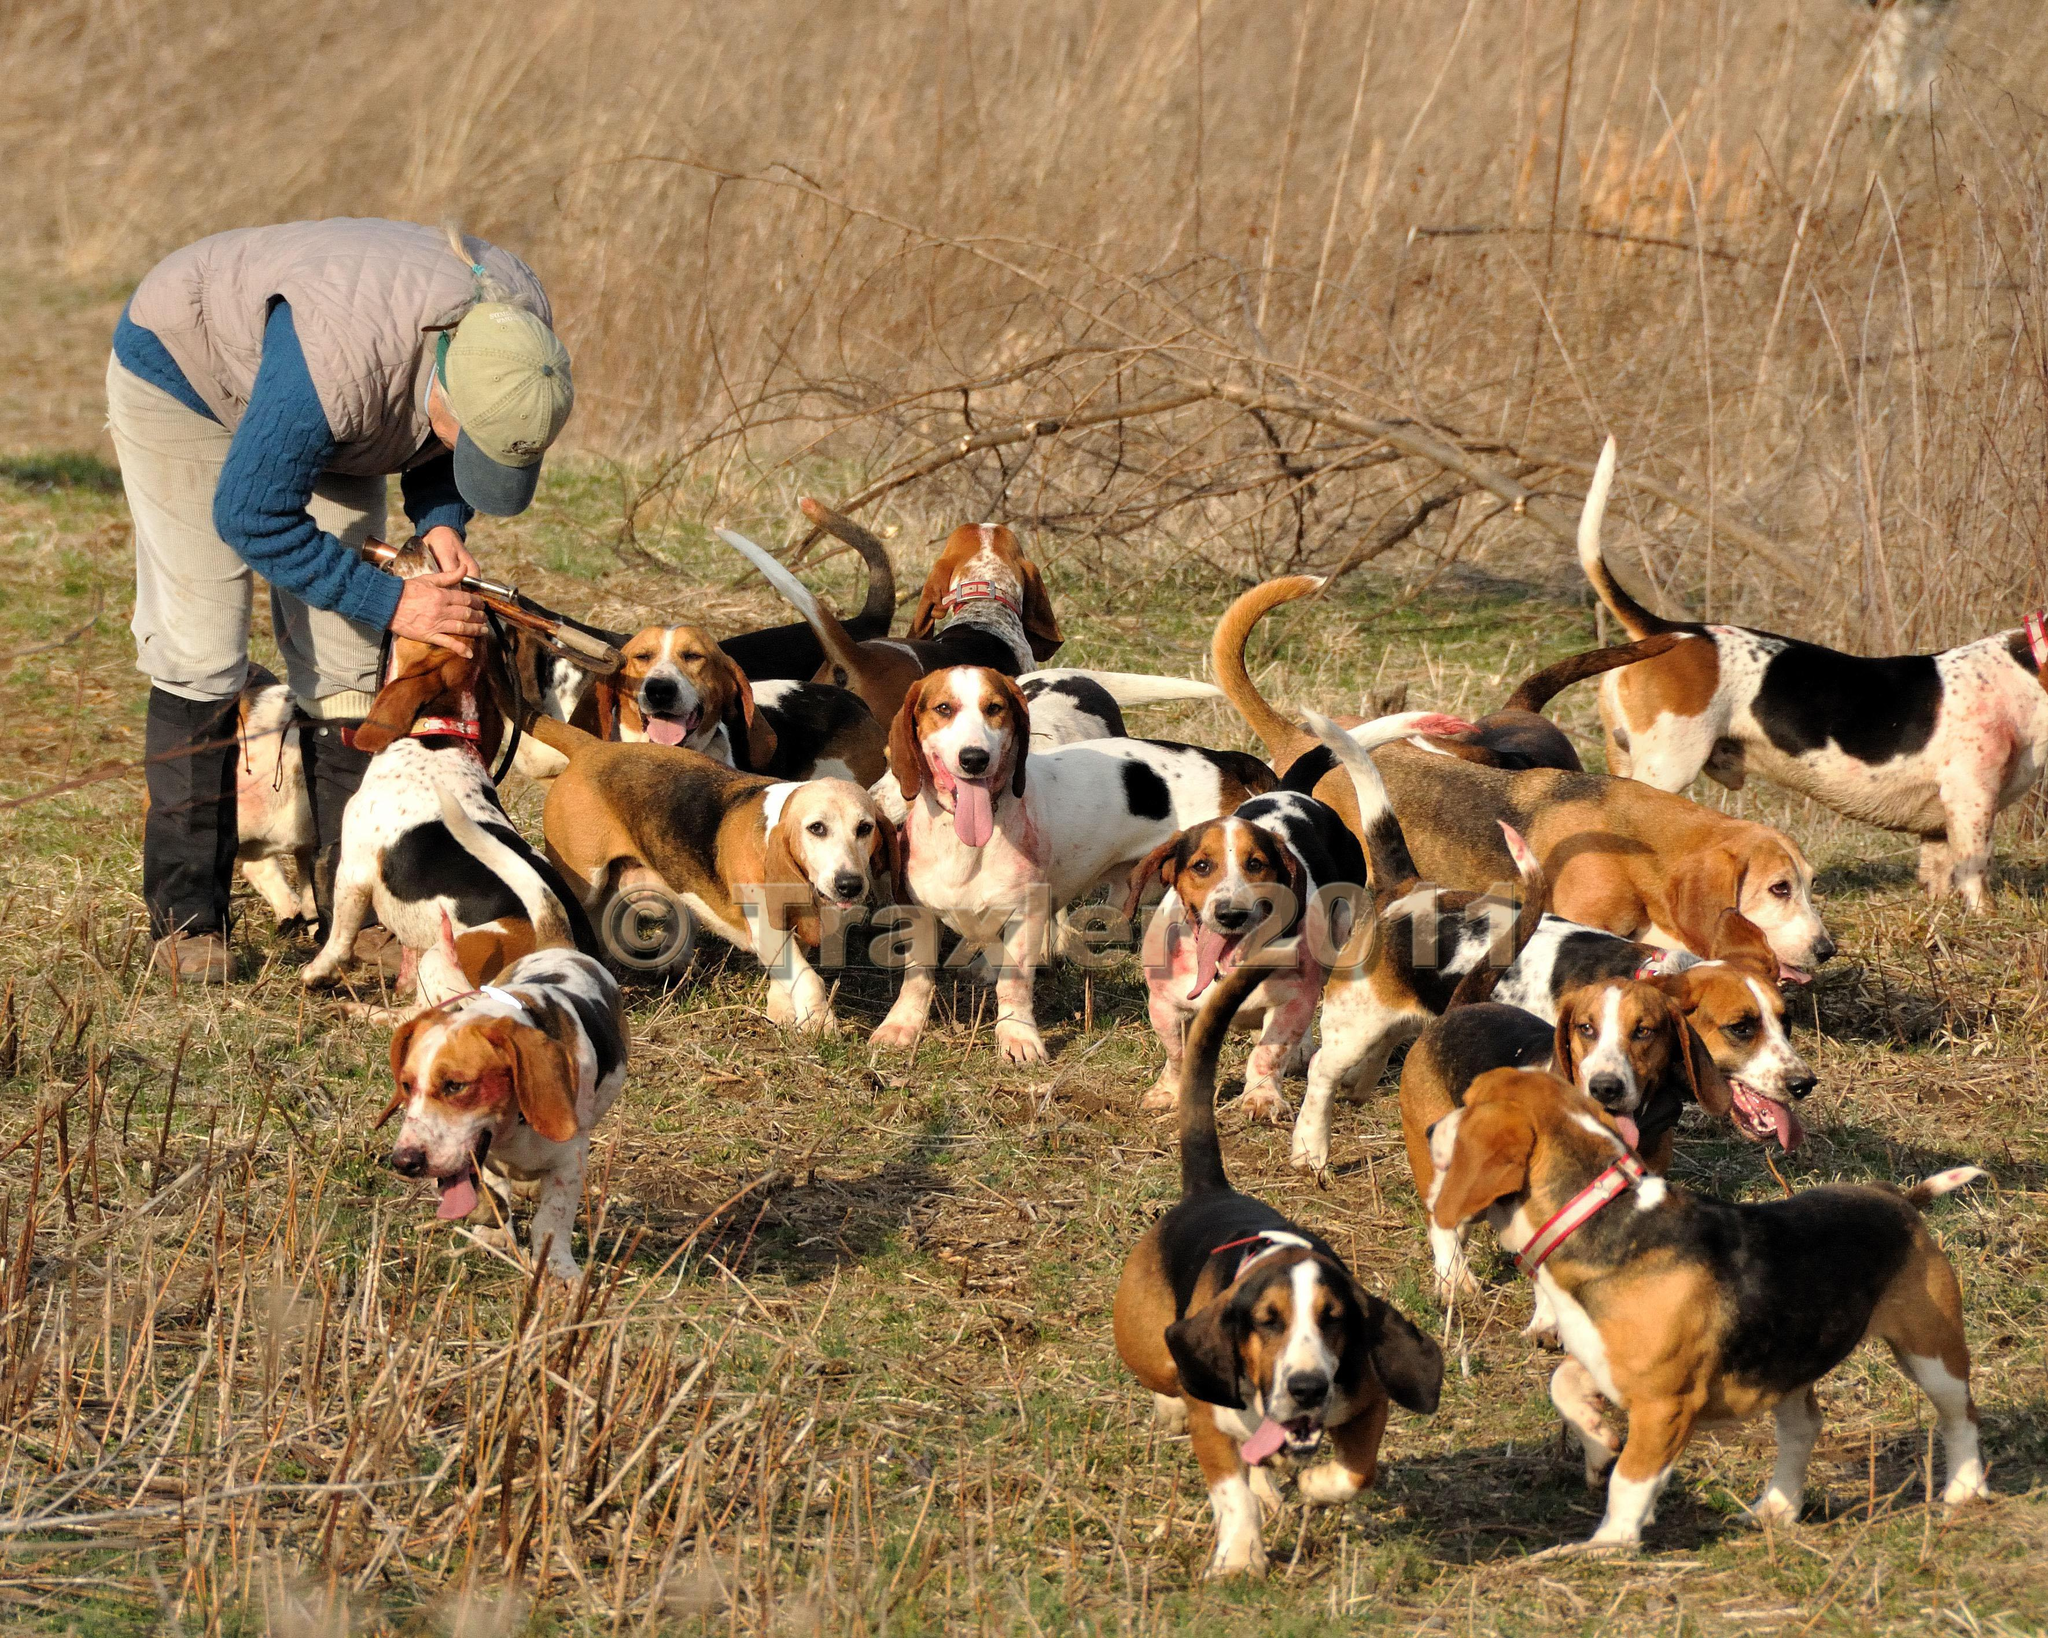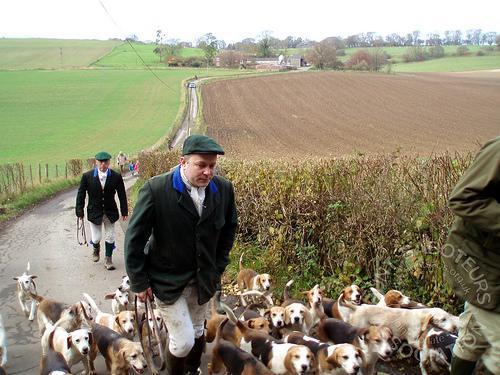The first image is the image on the left, the second image is the image on the right. Evaluate the accuracy of this statement regarding the images: "One image has no more than one dog.". Is it true? Answer yes or no. No. The first image is the image on the left, the second image is the image on the right. Assess this claim about the two images: "in at least one photo a man is using a walking stick on the grass". Correct or not? Answer yes or no. No. The first image is the image on the left, the second image is the image on the right. Evaluate the accuracy of this statement regarding the images: "An image shows multiple men in blazers, caps and tall socks over pants standing near a pack of hounds.". Is it true? Answer yes or no. Yes. The first image is the image on the left, the second image is the image on the right. Analyze the images presented: Is the assertion "A single man poses with at least one dog in the image on the left." valid? Answer yes or no. Yes. 